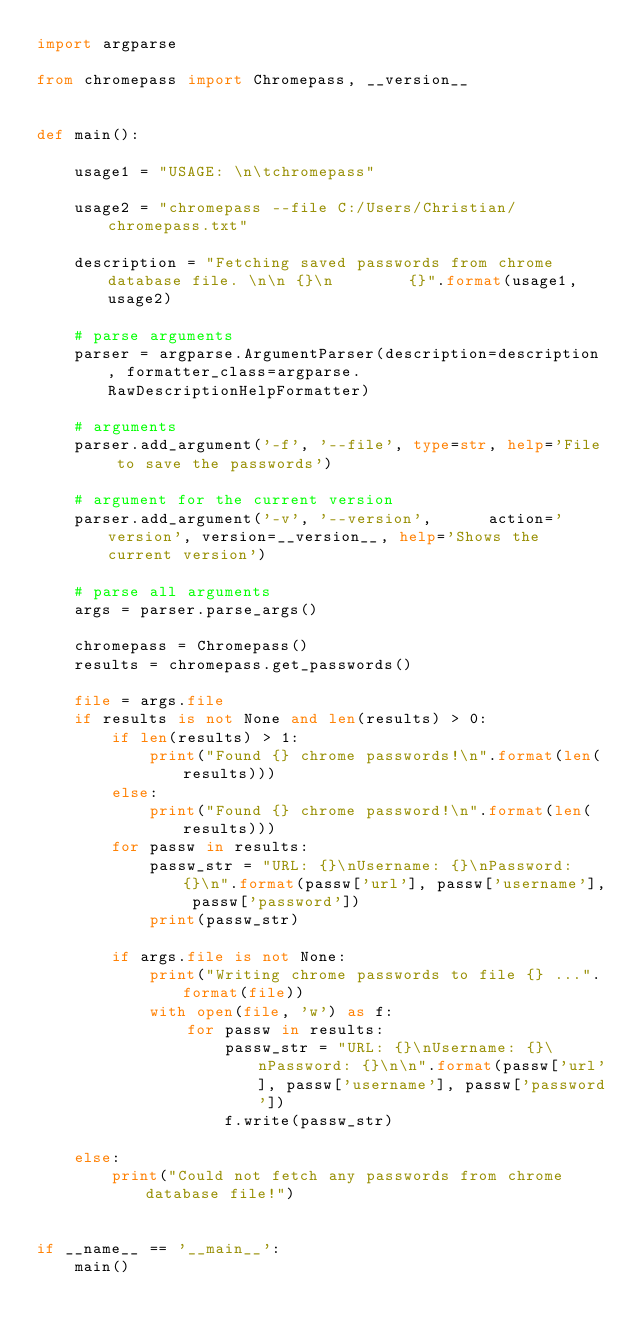<code> <loc_0><loc_0><loc_500><loc_500><_Python_>import argparse

from chromepass import Chromepass, __version__


def main():

    usage1 = "USAGE: \n\tchromepass"

    usage2 = "chromepass --file C:/Users/Christian/chromepass.txt"

    description = "Fetching saved passwords from chrome database file. \n\n {}\n        {}".format(usage1, usage2)

    # parse arguments
    parser = argparse.ArgumentParser(description=description, formatter_class=argparse.RawDescriptionHelpFormatter)

    # arguments
    parser.add_argument('-f', '--file', type=str, help='File to save the passwords')

    # argument for the current version
    parser.add_argument('-v', '--version',      action='version', version=__version__, help='Shows the current version')

    # parse all arguments
    args = parser.parse_args()

    chromepass = Chromepass()
    results = chromepass.get_passwords()

    file = args.file
    if results is not None and len(results) > 0:
        if len(results) > 1:
            print("Found {} chrome passwords!\n".format(len(results)))
        else:
            print("Found {} chrome password!\n".format(len(results)))
        for passw in results:
            passw_str = "URL: {}\nUsername: {}\nPassword: {}\n".format(passw['url'], passw['username'], passw['password'])
            print(passw_str)

        if args.file is not None:
            print("Writing chrome passwords to file {} ...".format(file))
            with open(file, 'w') as f:
                for passw in results:
                    passw_str = "URL: {}\nUsername: {}\nPassword: {}\n\n".format(passw['url'], passw['username'], passw['password'])
                    f.write(passw_str)

    else:
        print("Could not fetch any passwords from chrome database file!")


if __name__ == '__main__':
    main()
</code> 